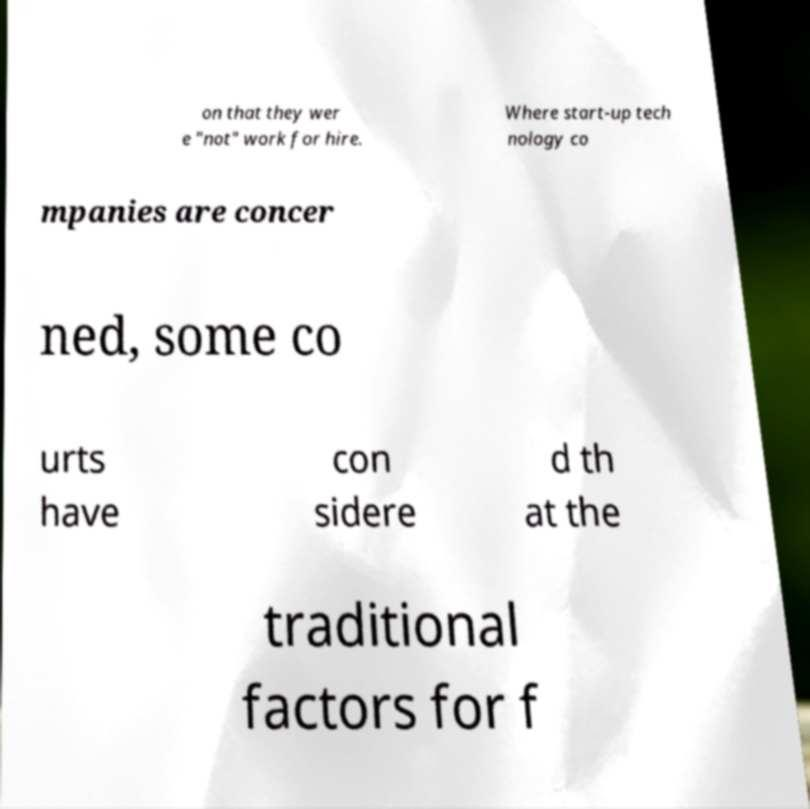Could you assist in decoding the text presented in this image and type it out clearly? on that they wer e "not" work for hire. Where start-up tech nology co mpanies are concer ned, some co urts have con sidere d th at the traditional factors for f 